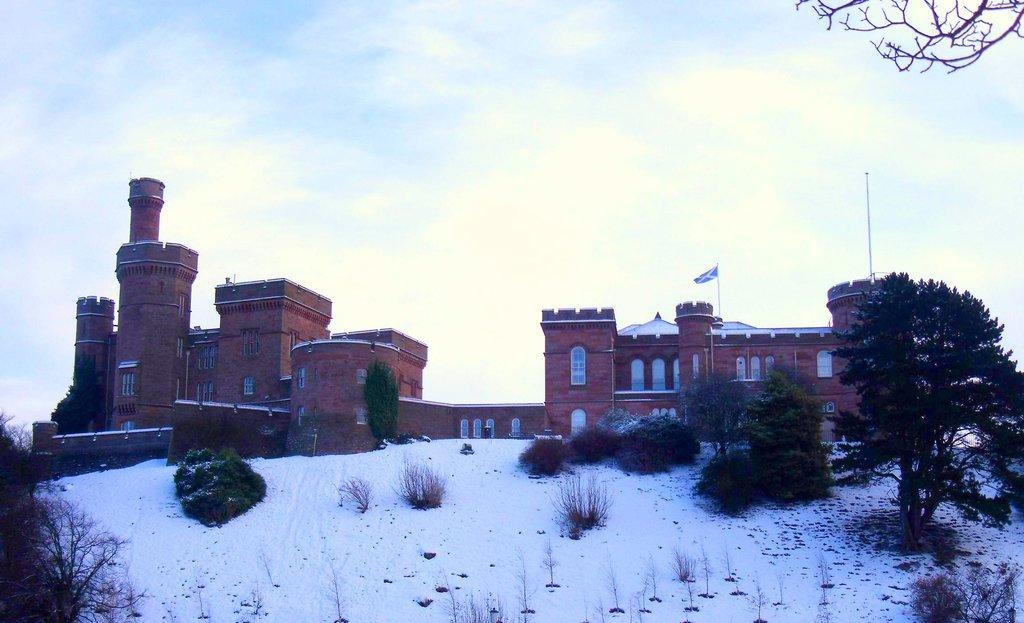What type of structure is present in the image? There is a building in the image. What is the color of the building? The building is brown. Where is the flag located in the image? The flag is on the right side of the image. What type of vegetation is present in the image? There are trees in the image. What is the color of the trees? The trees are green. What type of weather condition is depicted in the image? There is snow in the image. What is the color of the snow? The snow is white. What is the color of the sky in the image? The sky is blue and white. How many chickens are sitting on the note in the image? There are no chickens or notes present in the image. What is the hope of the person holding the chickens in the image? There are no people, chickens, or hope depicted in the image. 